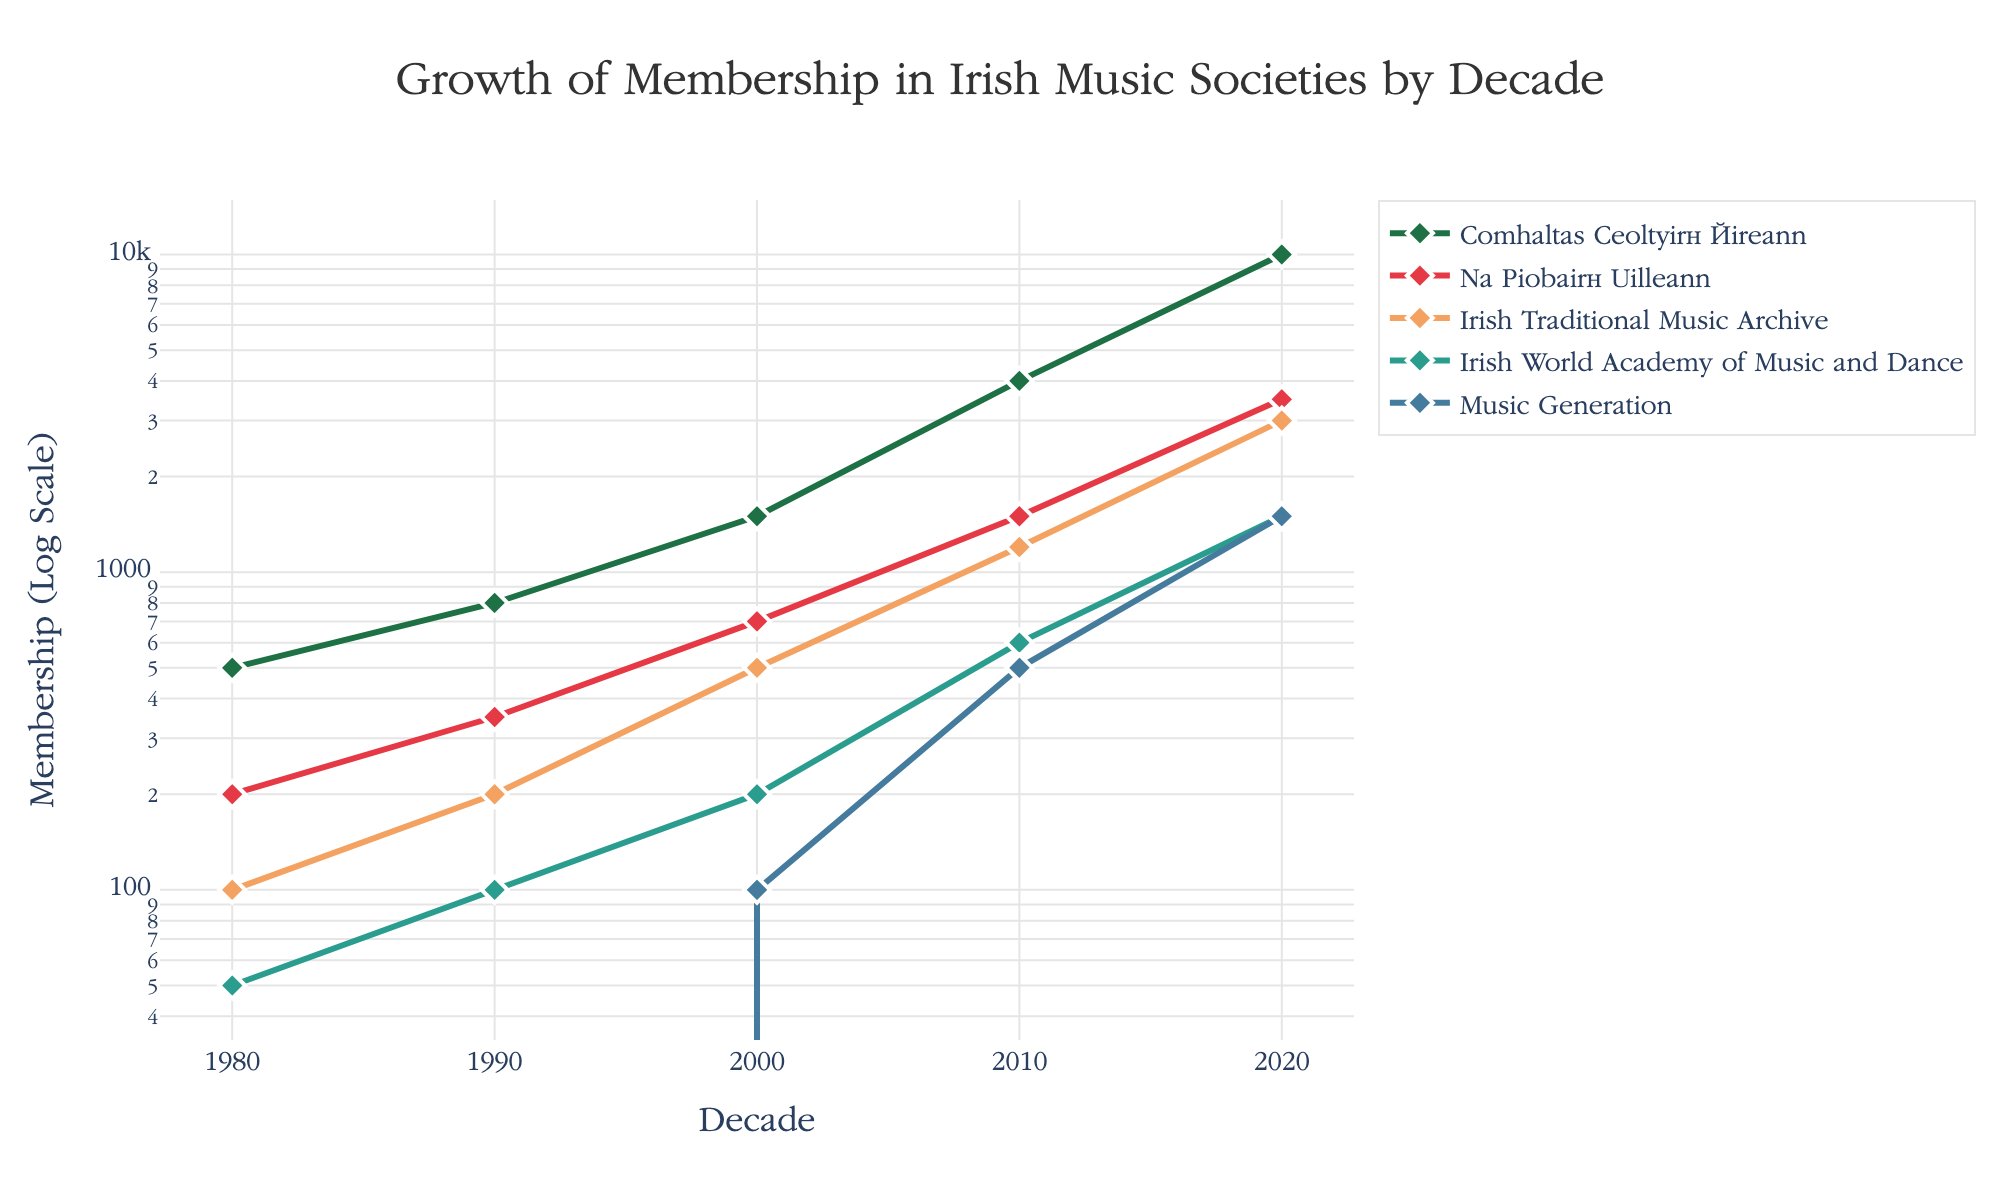What is the title of the figure? The title of a figure is usually placed at the top and it's intended to summarize the main content. Look at the top center of the figure to find the title.
Answer: Growth of Membership in Irish Music Societies by Decade What are the y-axis units? The y-axis label describes the units used to measure the variable plotted along the y-axis. Observe the label on the y-axis to determine this.
Answer: Membership (Log Scale) Which society had the highest membership in 2020? Identify the point on the x-axis for the year 2020 and then check which line reaches the highest point. The legend will help associate the line color with the society.
Answer: Comhaltas Ceoltóirí Éireann How has the membership of Music Generation changed over the decades? Find the points along the line representing Music Generation in each decade. Compare the values at each decade to understand the growth trend over time.
Answer: The membership increased from 100 in 2000 to 500 in 2010 and up to 1500 in 2020 By how much did the membership of Na Piobairí Uilleann increase from 2000 to 2020? Identify the y-values for Na Piobairí Uilleann in the years 2000 and 2020. Subtract the value in 2000 from the value in 2020 to find the increase.
Answer: 2800 Which society experienced the fastest growth between 1980 and 2020? Compare the slope of each society's line from 1980 to 2020. A steeper slope indicates faster growth.
Answer: Comhaltas Ceoltóirí Éireann In which decade did the Irish World Academy of Music and Dance first appear in the membership data? Look for the first non-zero data point along the Irish World Academy of Music and Dance line. Identify the corresponding x-axis value (decade).
Answer: 1980 How does the membership trend of the Irish Traditional Music Archive compare to that of Comhaltas Ceoltóirí Éireann? Compare the slopes and positions of the lines representing these two societies to understand how their memberships have changed relative to each other over the decades.
Answer: The membership of Comhaltas Ceoltóirí Éireann grows much faster than that of the Irish Traditional Music Archive 